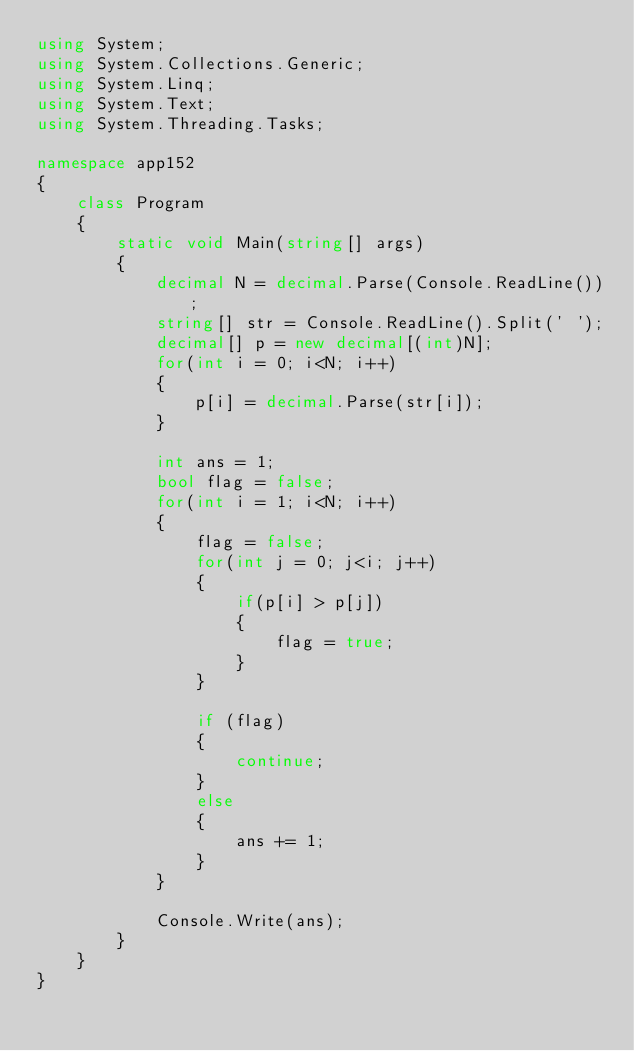Convert code to text. <code><loc_0><loc_0><loc_500><loc_500><_C#_>using System;
using System.Collections.Generic;
using System.Linq;
using System.Text;
using System.Threading.Tasks;

namespace app152
{
    class Program
    {
        static void Main(string[] args)
        {
            decimal N = decimal.Parse(Console.ReadLine());
            string[] str = Console.ReadLine().Split(' ');
            decimal[] p = new decimal[(int)N];
            for(int i = 0; i<N; i++)
            {
                p[i] = decimal.Parse(str[i]);
            }

            int ans = 1;
            bool flag = false;
            for(int i = 1; i<N; i++)
            {
                flag = false;
                for(int j = 0; j<i; j++)
                {
                    if(p[i] > p[j])
                    {
                        flag = true;
                    }
                }

                if (flag)
                {
                    continue;
                }
                else
                {
                    ans += 1;
                }
            }

            Console.Write(ans);
        }
    }
}
</code> 